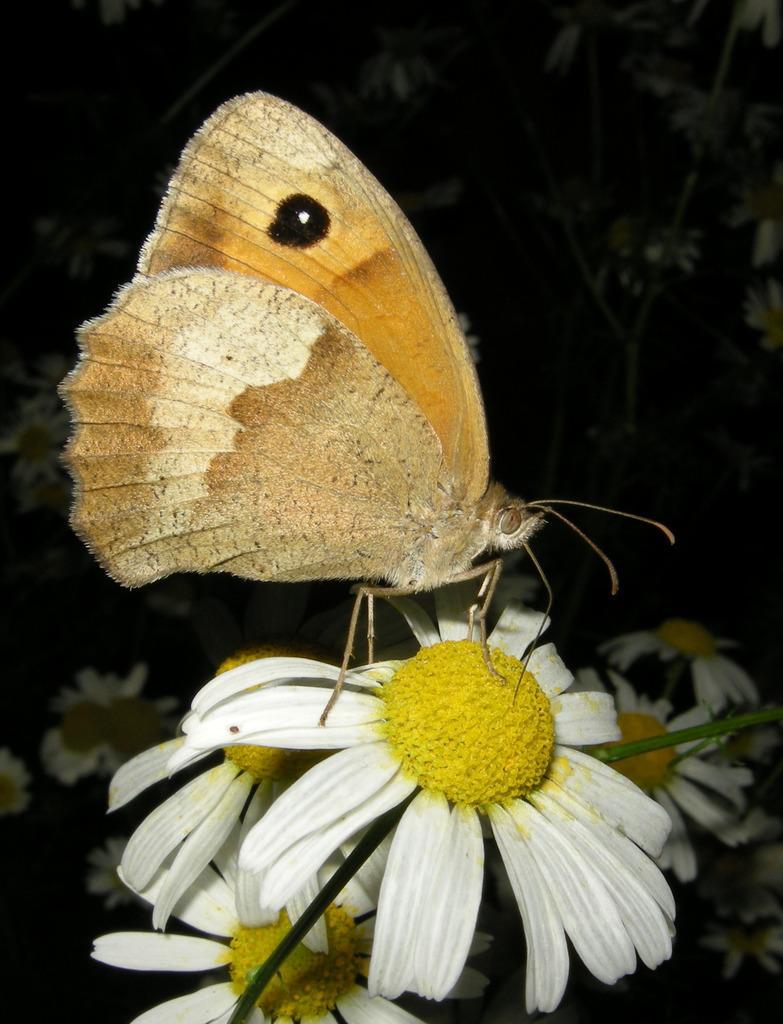In one or two sentences, can you explain what this image depicts? In this image we can see a butterfly on the white color flower. The background of the image is dark, where we can see a few more flowers and plants. 